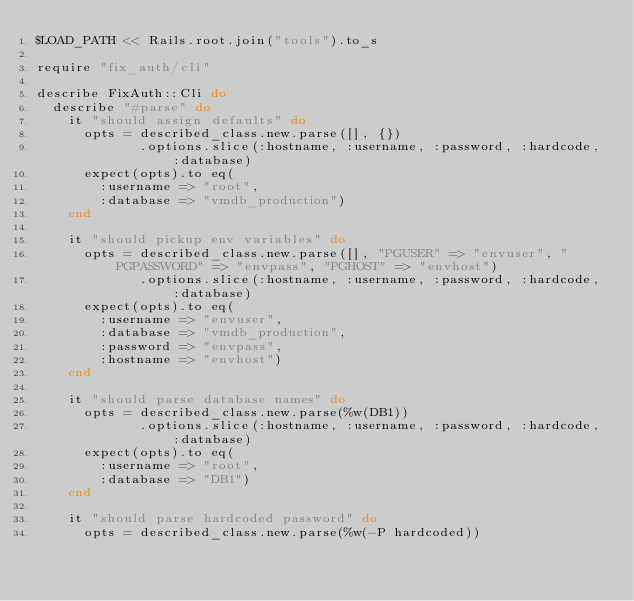<code> <loc_0><loc_0><loc_500><loc_500><_Ruby_>$LOAD_PATH << Rails.root.join("tools").to_s

require "fix_auth/cli"

describe FixAuth::Cli do
  describe "#parse" do
    it "should assign defaults" do
      opts = described_class.new.parse([], {})
             .options.slice(:hostname, :username, :password, :hardcode, :database)
      expect(opts).to eq(
        :username => "root",
        :database => "vmdb_production")
    end

    it "should pickup env variables" do
      opts = described_class.new.parse([], "PGUSER" => "envuser", "PGPASSWORD" => "envpass", "PGHOST" => "envhost")
             .options.slice(:hostname, :username, :password, :hardcode, :database)
      expect(opts).to eq(
        :username => "envuser",
        :database => "vmdb_production",
        :password => "envpass",
        :hostname => "envhost")
    end

    it "should parse database names" do
      opts = described_class.new.parse(%w(DB1))
             .options.slice(:hostname, :username, :password, :hardcode, :database)
      expect(opts).to eq(
        :username => "root",
        :database => "DB1")
    end

    it "should parse hardcoded password" do
      opts = described_class.new.parse(%w(-P hardcoded))</code> 